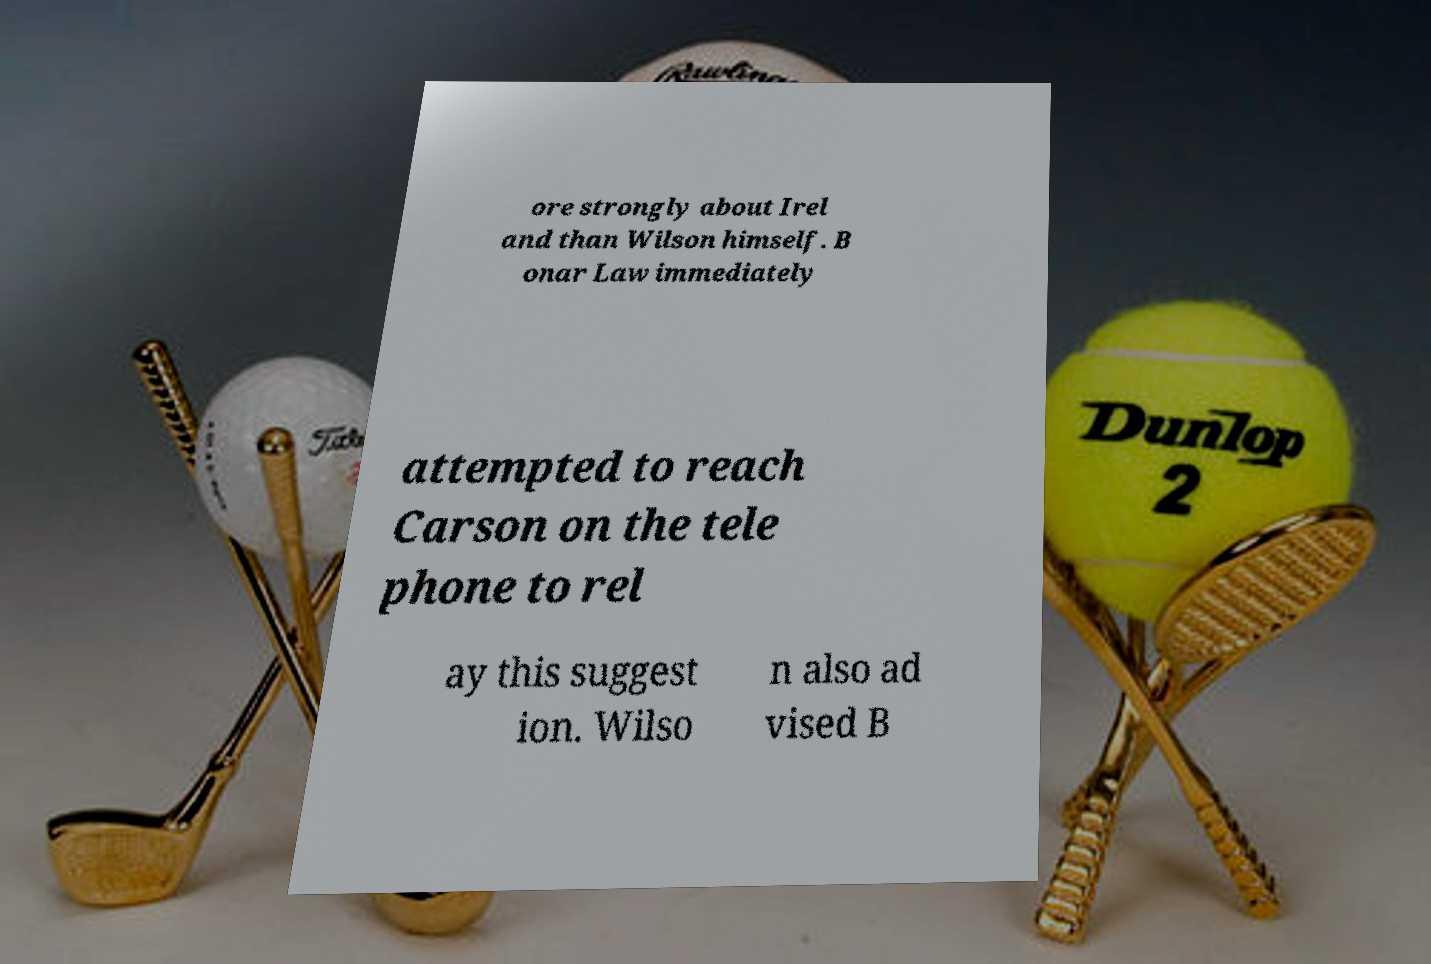Could you assist in decoding the text presented in this image and type it out clearly? ore strongly about Irel and than Wilson himself. B onar Law immediately attempted to reach Carson on the tele phone to rel ay this suggest ion. Wilso n also ad vised B 